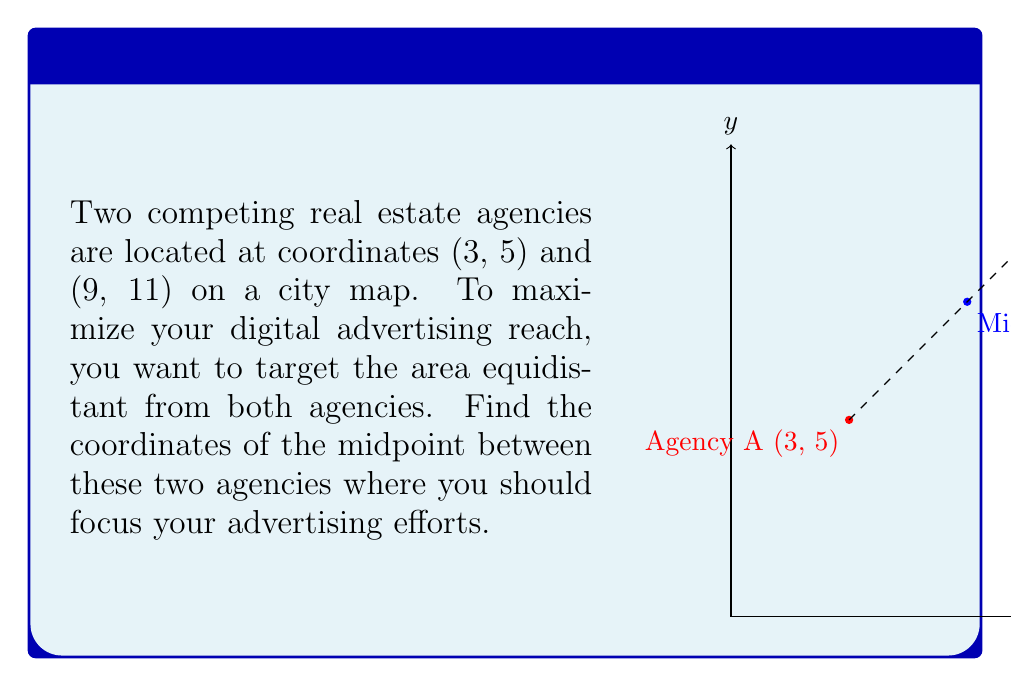Help me with this question. To find the midpoint between two points, we use the midpoint formula:

$$ \text{Midpoint} = \left(\frac{x_1 + x_2}{2}, \frac{y_1 + y_2}{2}\right) $$

Where $(x_1, y_1)$ are the coordinates of the first point and $(x_2, y_2)$ are the coordinates of the second point.

Given:
- Agency A is at (3, 5)
- Agency B is at (9, 11)

Step 1: Calculate the x-coordinate of the midpoint:
$$ x = \frac{x_1 + x_2}{2} = \frac{3 + 9}{2} = \frac{12}{2} = 6 $$

Step 2: Calculate the y-coordinate of the midpoint:
$$ y = \frac{y_1 + y_2}{2} = \frac{5 + 11}{2} = \frac{16}{2} = 8 $$

Therefore, the midpoint between the two agencies is (6, 8).
Answer: (6, 8) 